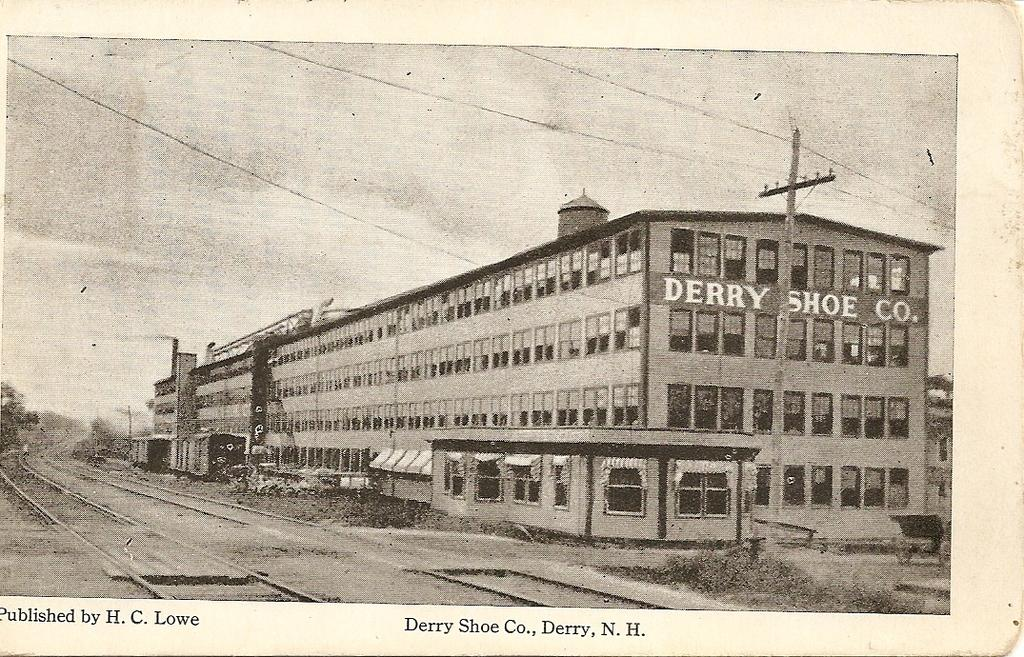What type of image is depicted in the photograph? The image contains an old photograph. What can be seen on the ground in the photograph? The ground is visible in the photograph. What type of vegetation is present in the photograph? There are trees in the photograph. What type of transportation infrastructure is present in the photograph? Railway tracks are present in the photograph. What type of vehicles can be seen in the photograph? Vehicles are visible in the photograph. What type of structure is present in the photograph? There is a pole in the photograph. What type of building is present in the photograph? There is a building in the photograph. What part of the natural environment is visible in the background of the photograph? The sky is visible in the background of the photograph. What type of quiver can be seen in the photograph? There is no quiver present in the photograph. How does the sky use the vehicles in the photograph? The sky does not use the vehicles in the photograph; it is a natural element in the background. 